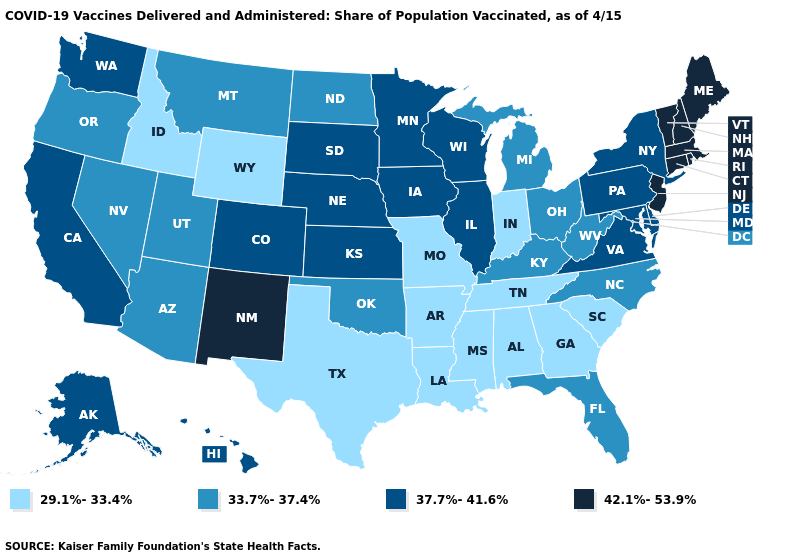What is the lowest value in the MidWest?
Short answer required. 29.1%-33.4%. Name the states that have a value in the range 33.7%-37.4%?
Quick response, please. Arizona, Florida, Kentucky, Michigan, Montana, Nevada, North Carolina, North Dakota, Ohio, Oklahoma, Oregon, Utah, West Virginia. What is the value of Utah?
Keep it brief. 33.7%-37.4%. What is the value of Pennsylvania?
Give a very brief answer. 37.7%-41.6%. Does Iowa have the same value as Oregon?
Answer briefly. No. What is the value of North Carolina?
Short answer required. 33.7%-37.4%. Name the states that have a value in the range 42.1%-53.9%?
Keep it brief. Connecticut, Maine, Massachusetts, New Hampshire, New Jersey, New Mexico, Rhode Island, Vermont. Does New Hampshire have the same value as Oregon?
Quick response, please. No. How many symbols are there in the legend?
Give a very brief answer. 4. What is the value of Washington?
Concise answer only. 37.7%-41.6%. What is the value of Kentucky?
Concise answer only. 33.7%-37.4%. What is the lowest value in states that border Illinois?
Keep it brief. 29.1%-33.4%. Does Wisconsin have the lowest value in the USA?
Be succinct. No. What is the lowest value in the South?
Concise answer only. 29.1%-33.4%. How many symbols are there in the legend?
Short answer required. 4. 